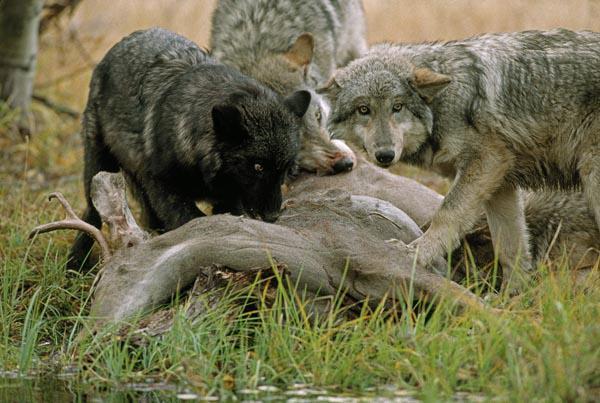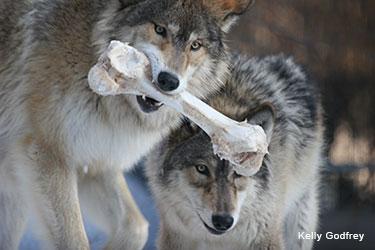The first image is the image on the left, the second image is the image on the right. Assess this claim about the two images: "There's no more than two wolves in the right image.". Correct or not? Answer yes or no. Yes. The first image is the image on the left, the second image is the image on the right. For the images shown, is this caption "All of the wolves are out in the snow." true? Answer yes or no. No. 